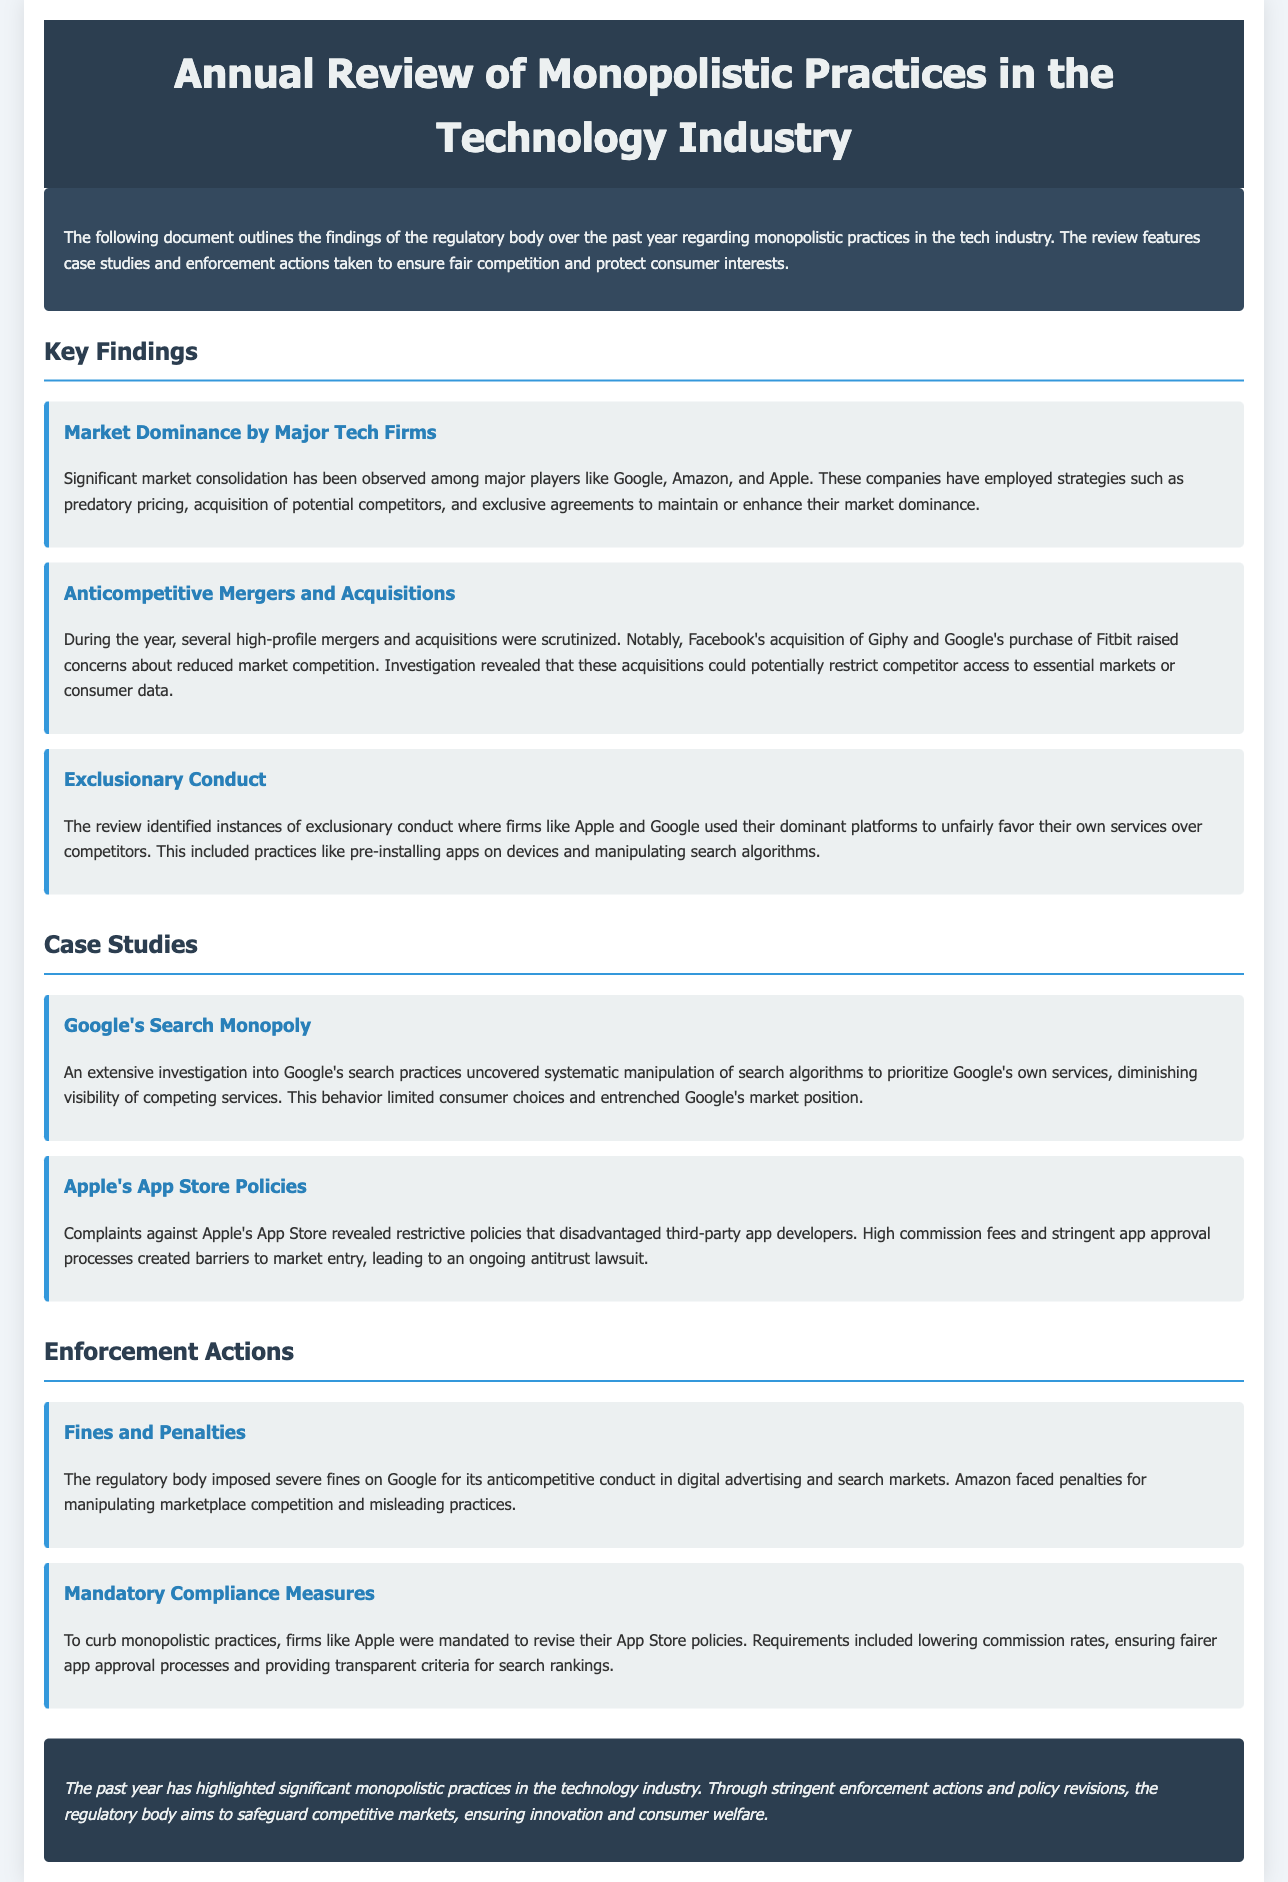What are the major tech firms mentioned? The document identifies major players in the tech industry, including Google, Amazon, and Apple, as significant contributors to market dominance.
Answer: Google, Amazon, Apple What was Facebook's acquisition that raised concerns? The document states that Facebook's acquisition of Giphy was scrutinized for its potential effects on market competition.
Answer: Giphy Which company's App Store policies are under scrutiny? The document highlights complaints against Apple's App Store policies, indicating active scrutiny regarding its practices.
Answer: Apple's What action did the regulatory body take against Google? The document mentions that the regulatory body imposed severe fines on Google for its anticompetitive conduct in specific markets.
Answer: Fines What type of compliance measures were mandated for Apple? The document outlines that Apple was required to revise its App Store policies, which include lowering commission rates and ensuring fair app approval processes.
Answer: Lowering commission rates What did the review highlight about monopolistic practices? The document concludes that the past year has highlighted significant monopolistic practices, drawing attention to the need for regulatory action.
Answer: Significant monopolistic practices What is one reason for scrutiny on anticompetitive mergers? The document mentions that mergers and acquisitions were scrutinized due to concerns that they could potentially restrict market competition.
Answer: Reduced market competition Which investigation focused on search practices? The document indicates that an extensive investigation focused on Google's search practices, analyzing algorithm manipulation.
Answer: Google's search practices 